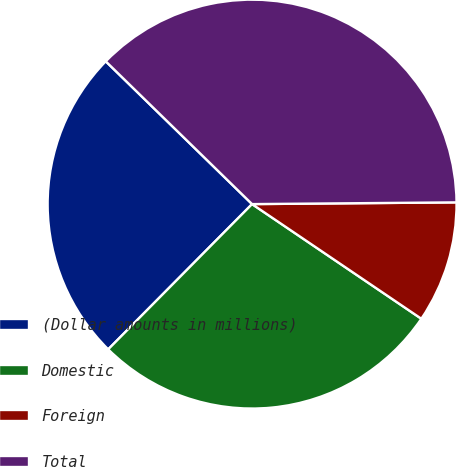<chart> <loc_0><loc_0><loc_500><loc_500><pie_chart><fcel>(Dollar amounts in millions)<fcel>Domestic<fcel>Foreign<fcel>Total<nl><fcel>24.88%<fcel>27.95%<fcel>9.61%<fcel>37.56%<nl></chart> 